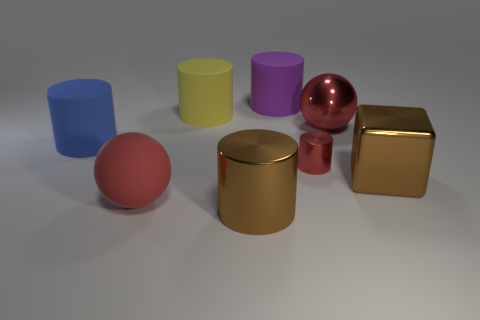Is there anything else that is the same color as the small metallic cylinder?
Make the answer very short. Yes. What is the color of the big ball that is on the left side of the red sphere behind the large red matte ball?
Provide a succinct answer. Red. Are any green rubber cubes visible?
Provide a short and direct response. No. What color is the large object that is both in front of the blue object and behind the red matte object?
Provide a succinct answer. Brown. There is a red sphere on the left side of the purple matte cylinder; is it the same size as the brown metal thing on the right side of the red metallic ball?
Provide a short and direct response. Yes. How many other objects are there of the same size as the red rubber sphere?
Your answer should be compact. 6. There is a brown object on the right side of the large red metal thing; how many big brown things are in front of it?
Ensure brevity in your answer.  1. Is the number of large metal spheres that are to the right of the big metal sphere less than the number of big brown metallic things?
Your response must be concise. Yes. There is a rubber thing right of the large metallic thing on the left side of the red ball that is behind the small cylinder; what shape is it?
Offer a terse response. Cylinder. Does the red matte object have the same shape as the blue thing?
Provide a short and direct response. No. 